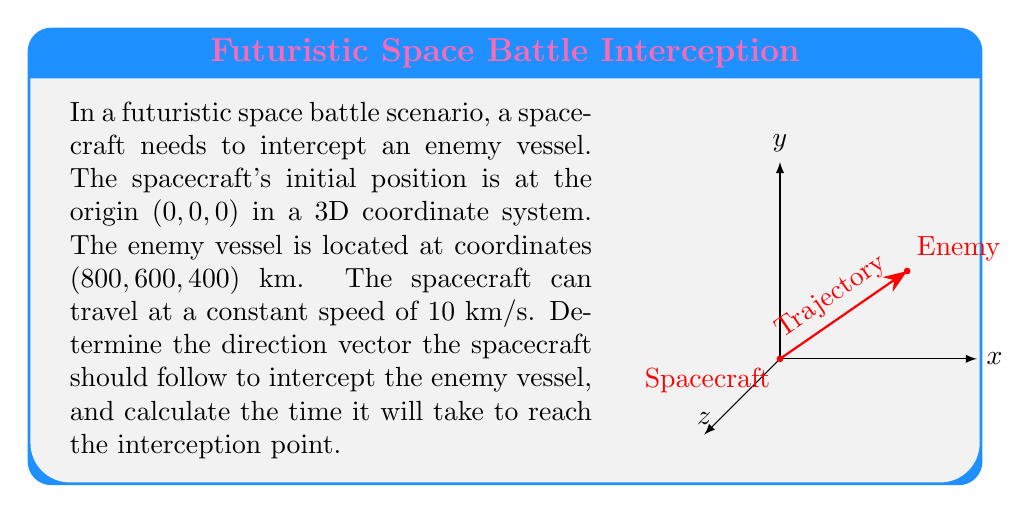Can you solve this math problem? Let's approach this step-by-step:

1) First, we need to find the vector from the spacecraft to the enemy vessel:
   $$\vec{v} = (800, 600, 400)$$

2) The magnitude of this vector gives us the distance:
   $$d = \sqrt{800^2 + 600^2 + 400^2} = \sqrt{1,160,000} = 1000 \text{ km}$$

3) To get the direction vector, we need to normalize $\vec{v}$. We do this by dividing $\vec{v}$ by its magnitude:
   $$\hat{v} = \frac{\vec{v}}{|\vec{v}|} = (\frac{800}{1000}, \frac{600}{1000}, \frac{400}{1000}) = (0.8, 0.6, 0.4)$$

4) This normalized vector $\hat{v}$ is the direction vector the spacecraft should follow.

5) To calculate the time, we use the formula: Time = Distance / Speed
   $$t = \frac{1000 \text{ km}}{10 \text{ km/s}} = 100 \text{ seconds}$$

Therefore, the spacecraft should follow the direction vector (0.8, 0.6, 0.4) and it will take 100 seconds to intercept the enemy vessel.
Answer: Direction vector: (0.8, 0.6, 0.4); Interception time: 100 seconds 